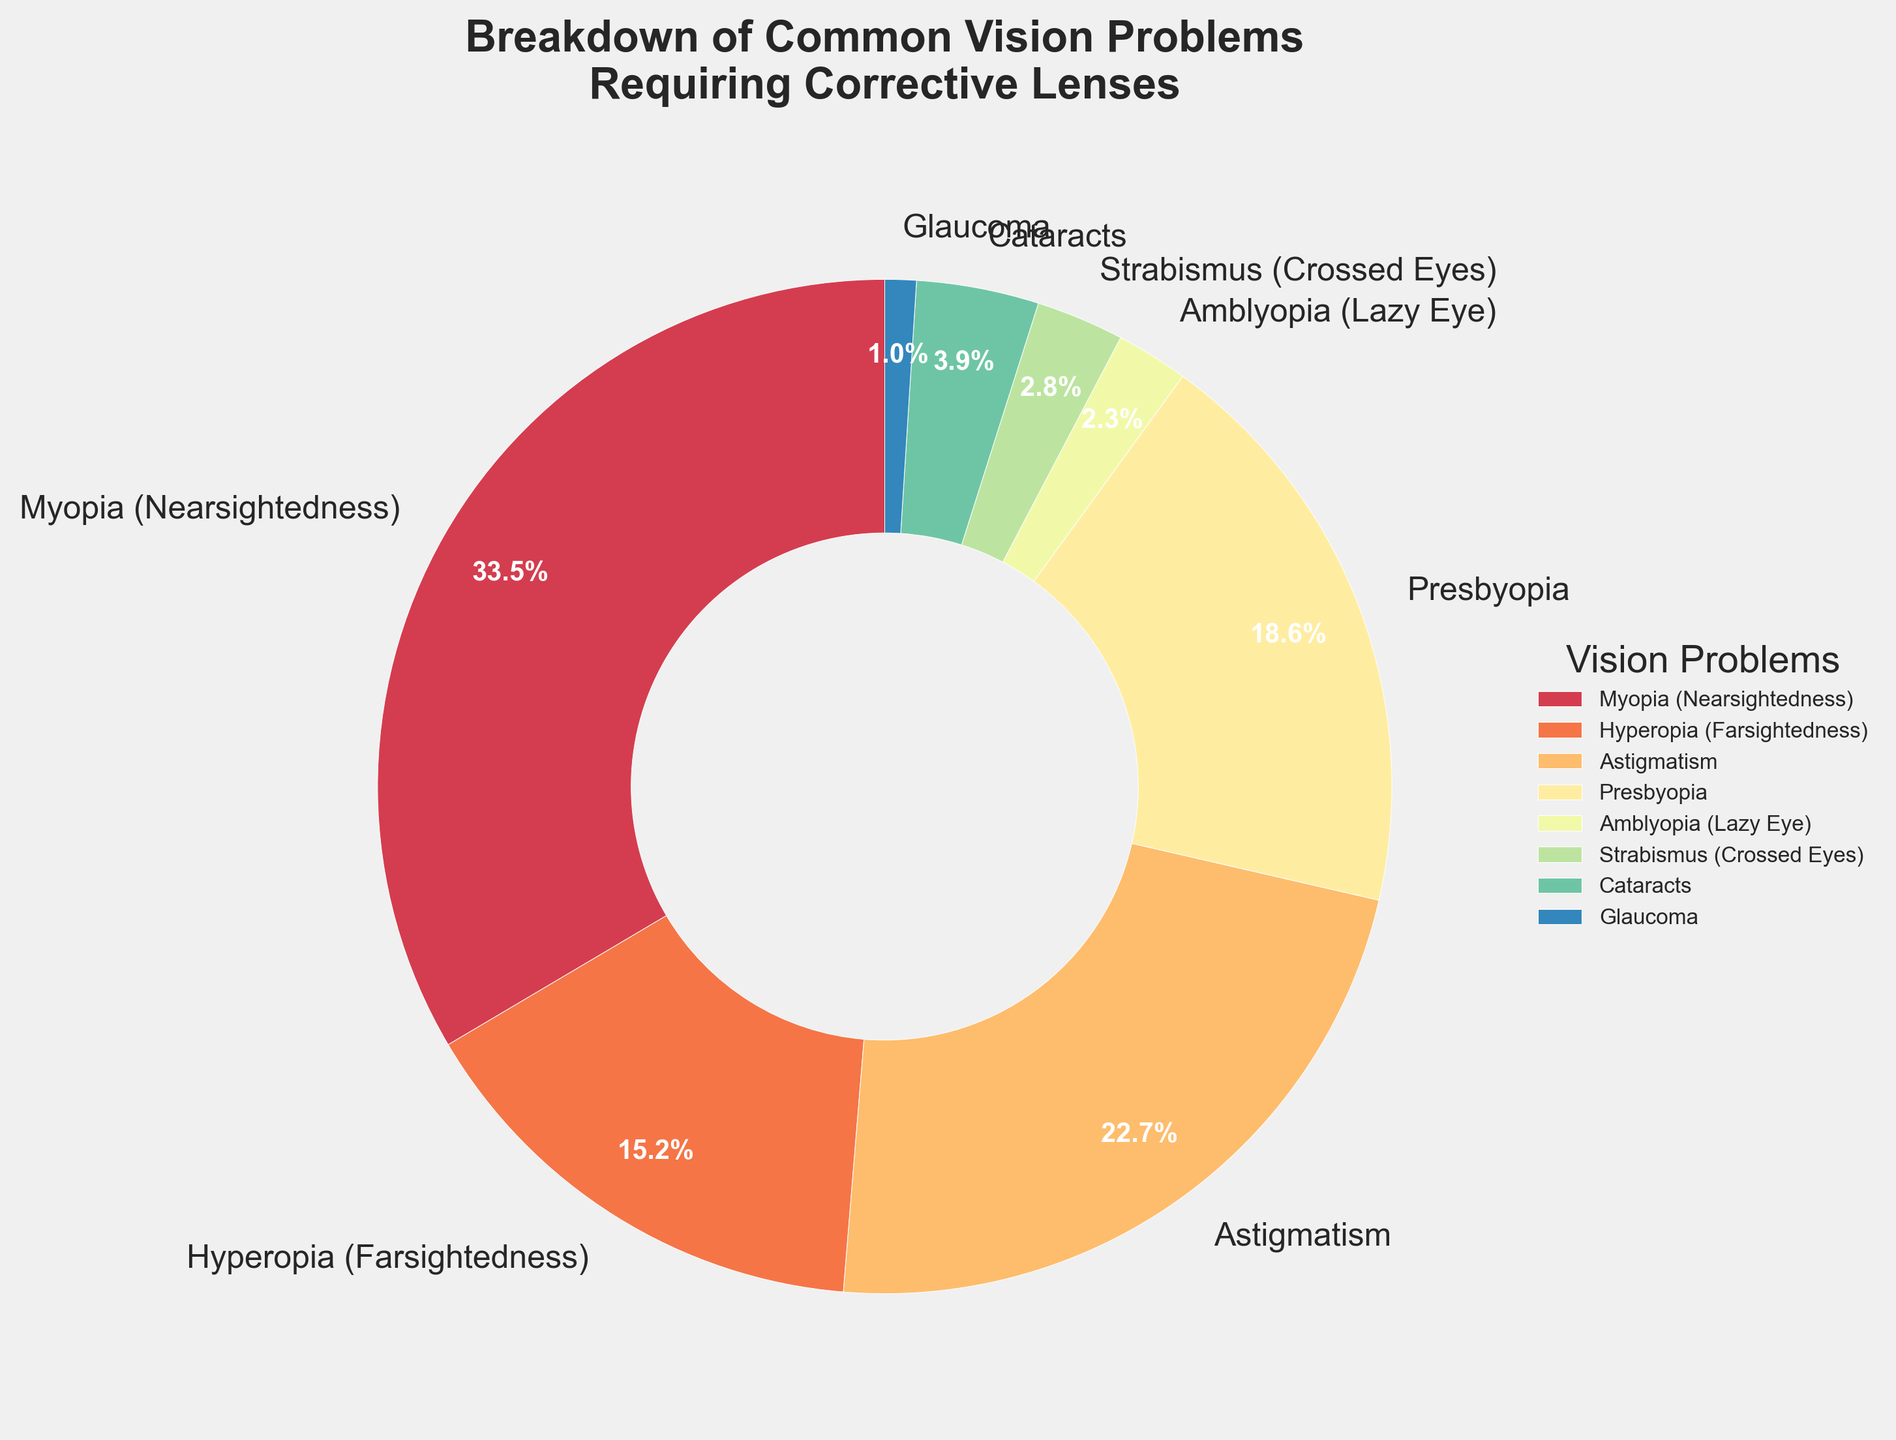What is the most common vision problem requiring corrective lenses? The most common vision problem is the one with the highest percentage in the pie chart. According to the chart, Myopia (Nearsightedness) has the highest percentage at 33.5%.
Answer: Myopia (Nearsightedness) Which vision problem has the smallest percentage? The smallest percentage will be indicated by the smallest wedge in the pie chart. Glaucoma shows the smallest percentage, which is 1.0%.
Answer: Glaucoma What is the combined percentage of Astigmatism and Presbyopia? Add the percentages for Astigmatism (22.7%) and Presbyopia (18.6%). The combined percentage is 22.7% + 18.6% = 41.3%.
Answer: 41.3% Which condition is more common, Amblyopia (Lazy Eye) or Strabismus (Crossed Eyes)? Compare the percentages of Amblyopia (2.3%) and Strabismus (2.8%). Strabismus has a higher percentage.
Answer: Strabismus (Crossed Eyes) Is Hyperopia (Farsightedness) or Astigmatism more prevalent? Compare the percentages of Hyperopia (15.2%) and Astigmatism (22.7%). Astigmatism is more prevalent.
Answer: Astigmatism What is the second most common vision problem requiring corrective lenses? The second most common problem is the one with the second highest percentage. The pie chart shows Myopia as the most common (33.5%), followed by Astigmatism at 22.7%. Therefore, Astigmatism is the second most common.
Answer: Astigmatism How do the combined percentages of cataracts and glaucoma compare to the percentage of presbyopia? Add the percentages for Cataracts (3.9%) and Glaucoma (1.0%) to get a combined percentage of 4.9%. Compare this to the percentage of Presbyopia (18.6%). The combined percentage is less than the percentage of Presbyopia.
Answer: Less than Which vision problem(s) have a percentage less than 5%? Check the pie chart for vision problems with percentages less than 5%. These problems are Amblyopia (2.3%), Strabismus (2.8%), Cataracts (3.9%), and Glaucoma (1.0%).
Answer: Amblyopia, Strabismus, Cataracts, Glaucoma 